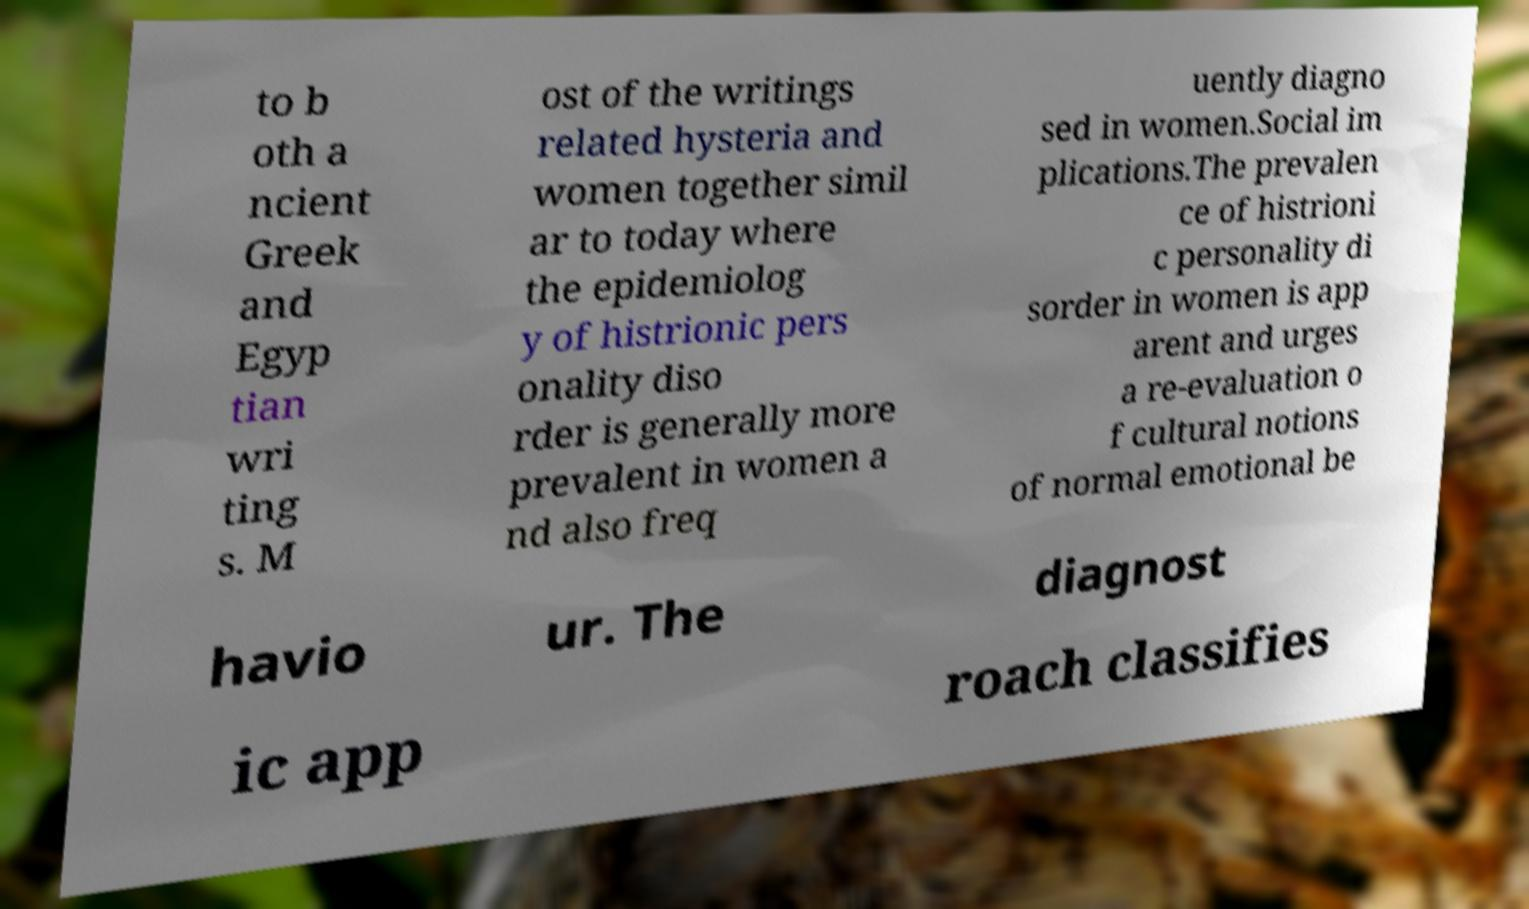Please read and relay the text visible in this image. What does it say? to b oth a ncient Greek and Egyp tian wri ting s. M ost of the writings related hysteria and women together simil ar to today where the epidemiolog y of histrionic pers onality diso rder is generally more prevalent in women a nd also freq uently diagno sed in women.Social im plications.The prevalen ce of histrioni c personality di sorder in women is app arent and urges a re-evaluation o f cultural notions of normal emotional be havio ur. The diagnost ic app roach classifies 